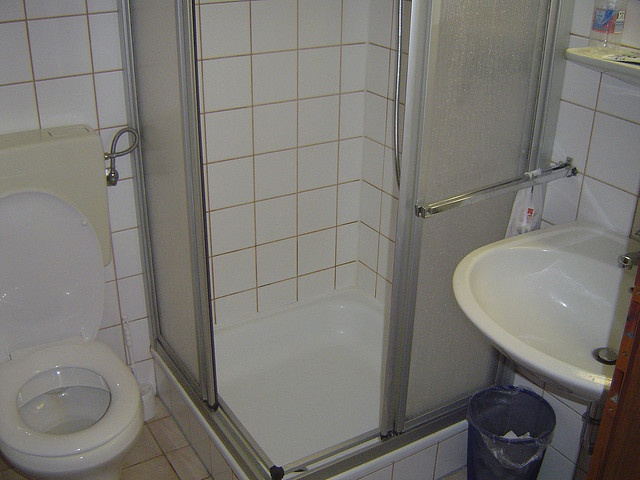Describe the objects in this image and their specific colors. I can see toilet in gray tones and sink in gray, darkgray, and black tones in this image. 